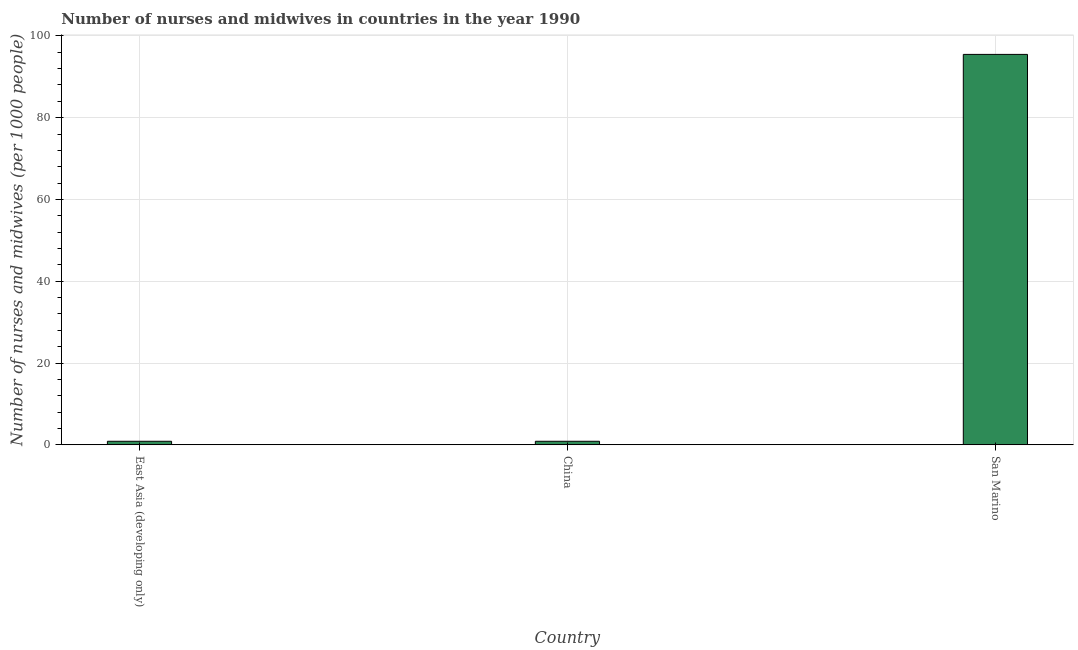What is the title of the graph?
Keep it short and to the point. Number of nurses and midwives in countries in the year 1990. What is the label or title of the Y-axis?
Your answer should be very brief. Number of nurses and midwives (per 1000 people). What is the number of nurses and midwives in San Marino?
Provide a succinct answer. 95.48. Across all countries, what is the maximum number of nurses and midwives?
Keep it short and to the point. 95.48. Across all countries, what is the minimum number of nurses and midwives?
Offer a terse response. 0.86. In which country was the number of nurses and midwives maximum?
Give a very brief answer. San Marino. In which country was the number of nurses and midwives minimum?
Offer a very short reply. East Asia (developing only). What is the sum of the number of nurses and midwives?
Provide a short and direct response. 97.2. What is the difference between the number of nurses and midwives in China and San Marino?
Your answer should be compact. -94.62. What is the average number of nurses and midwives per country?
Make the answer very short. 32.4. What is the median number of nurses and midwives?
Your answer should be compact. 0.86. In how many countries, is the number of nurses and midwives greater than 60 ?
Give a very brief answer. 1. What is the ratio of the number of nurses and midwives in China to that in San Marino?
Offer a terse response. 0.01. What is the difference between the highest and the second highest number of nurses and midwives?
Your answer should be very brief. 94.62. What is the difference between the highest and the lowest number of nurses and midwives?
Keep it short and to the point. 94.62. Are all the bars in the graph horizontal?
Provide a succinct answer. No. What is the Number of nurses and midwives (per 1000 people) of East Asia (developing only)?
Make the answer very short. 0.86. What is the Number of nurses and midwives (per 1000 people) in China?
Keep it short and to the point. 0.86. What is the Number of nurses and midwives (per 1000 people) of San Marino?
Ensure brevity in your answer.  95.48. What is the difference between the Number of nurses and midwives (per 1000 people) in East Asia (developing only) and China?
Your answer should be compact. 0. What is the difference between the Number of nurses and midwives (per 1000 people) in East Asia (developing only) and San Marino?
Provide a succinct answer. -94.62. What is the difference between the Number of nurses and midwives (per 1000 people) in China and San Marino?
Make the answer very short. -94.62. What is the ratio of the Number of nurses and midwives (per 1000 people) in East Asia (developing only) to that in China?
Offer a terse response. 1. What is the ratio of the Number of nurses and midwives (per 1000 people) in East Asia (developing only) to that in San Marino?
Keep it short and to the point. 0.01. What is the ratio of the Number of nurses and midwives (per 1000 people) in China to that in San Marino?
Your answer should be very brief. 0.01. 